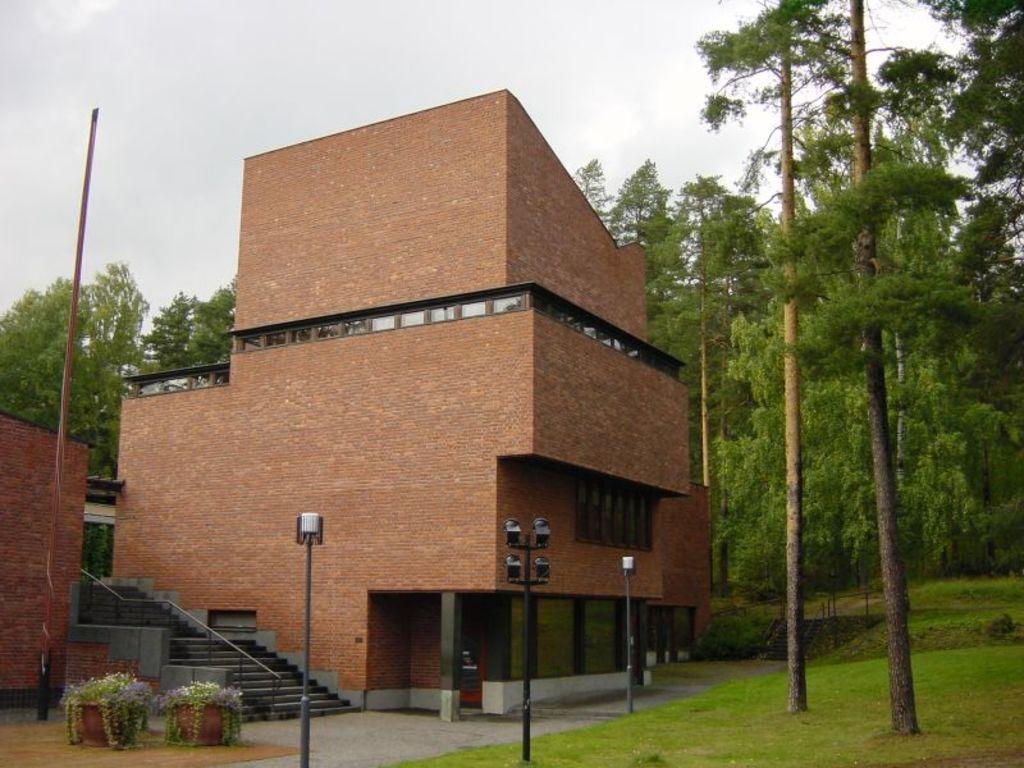Could you give a brief overview of what you see in this image? In this image I can see a building in front of building I can see poles, flower pot, plants and trees,at the top I can see the sky. 